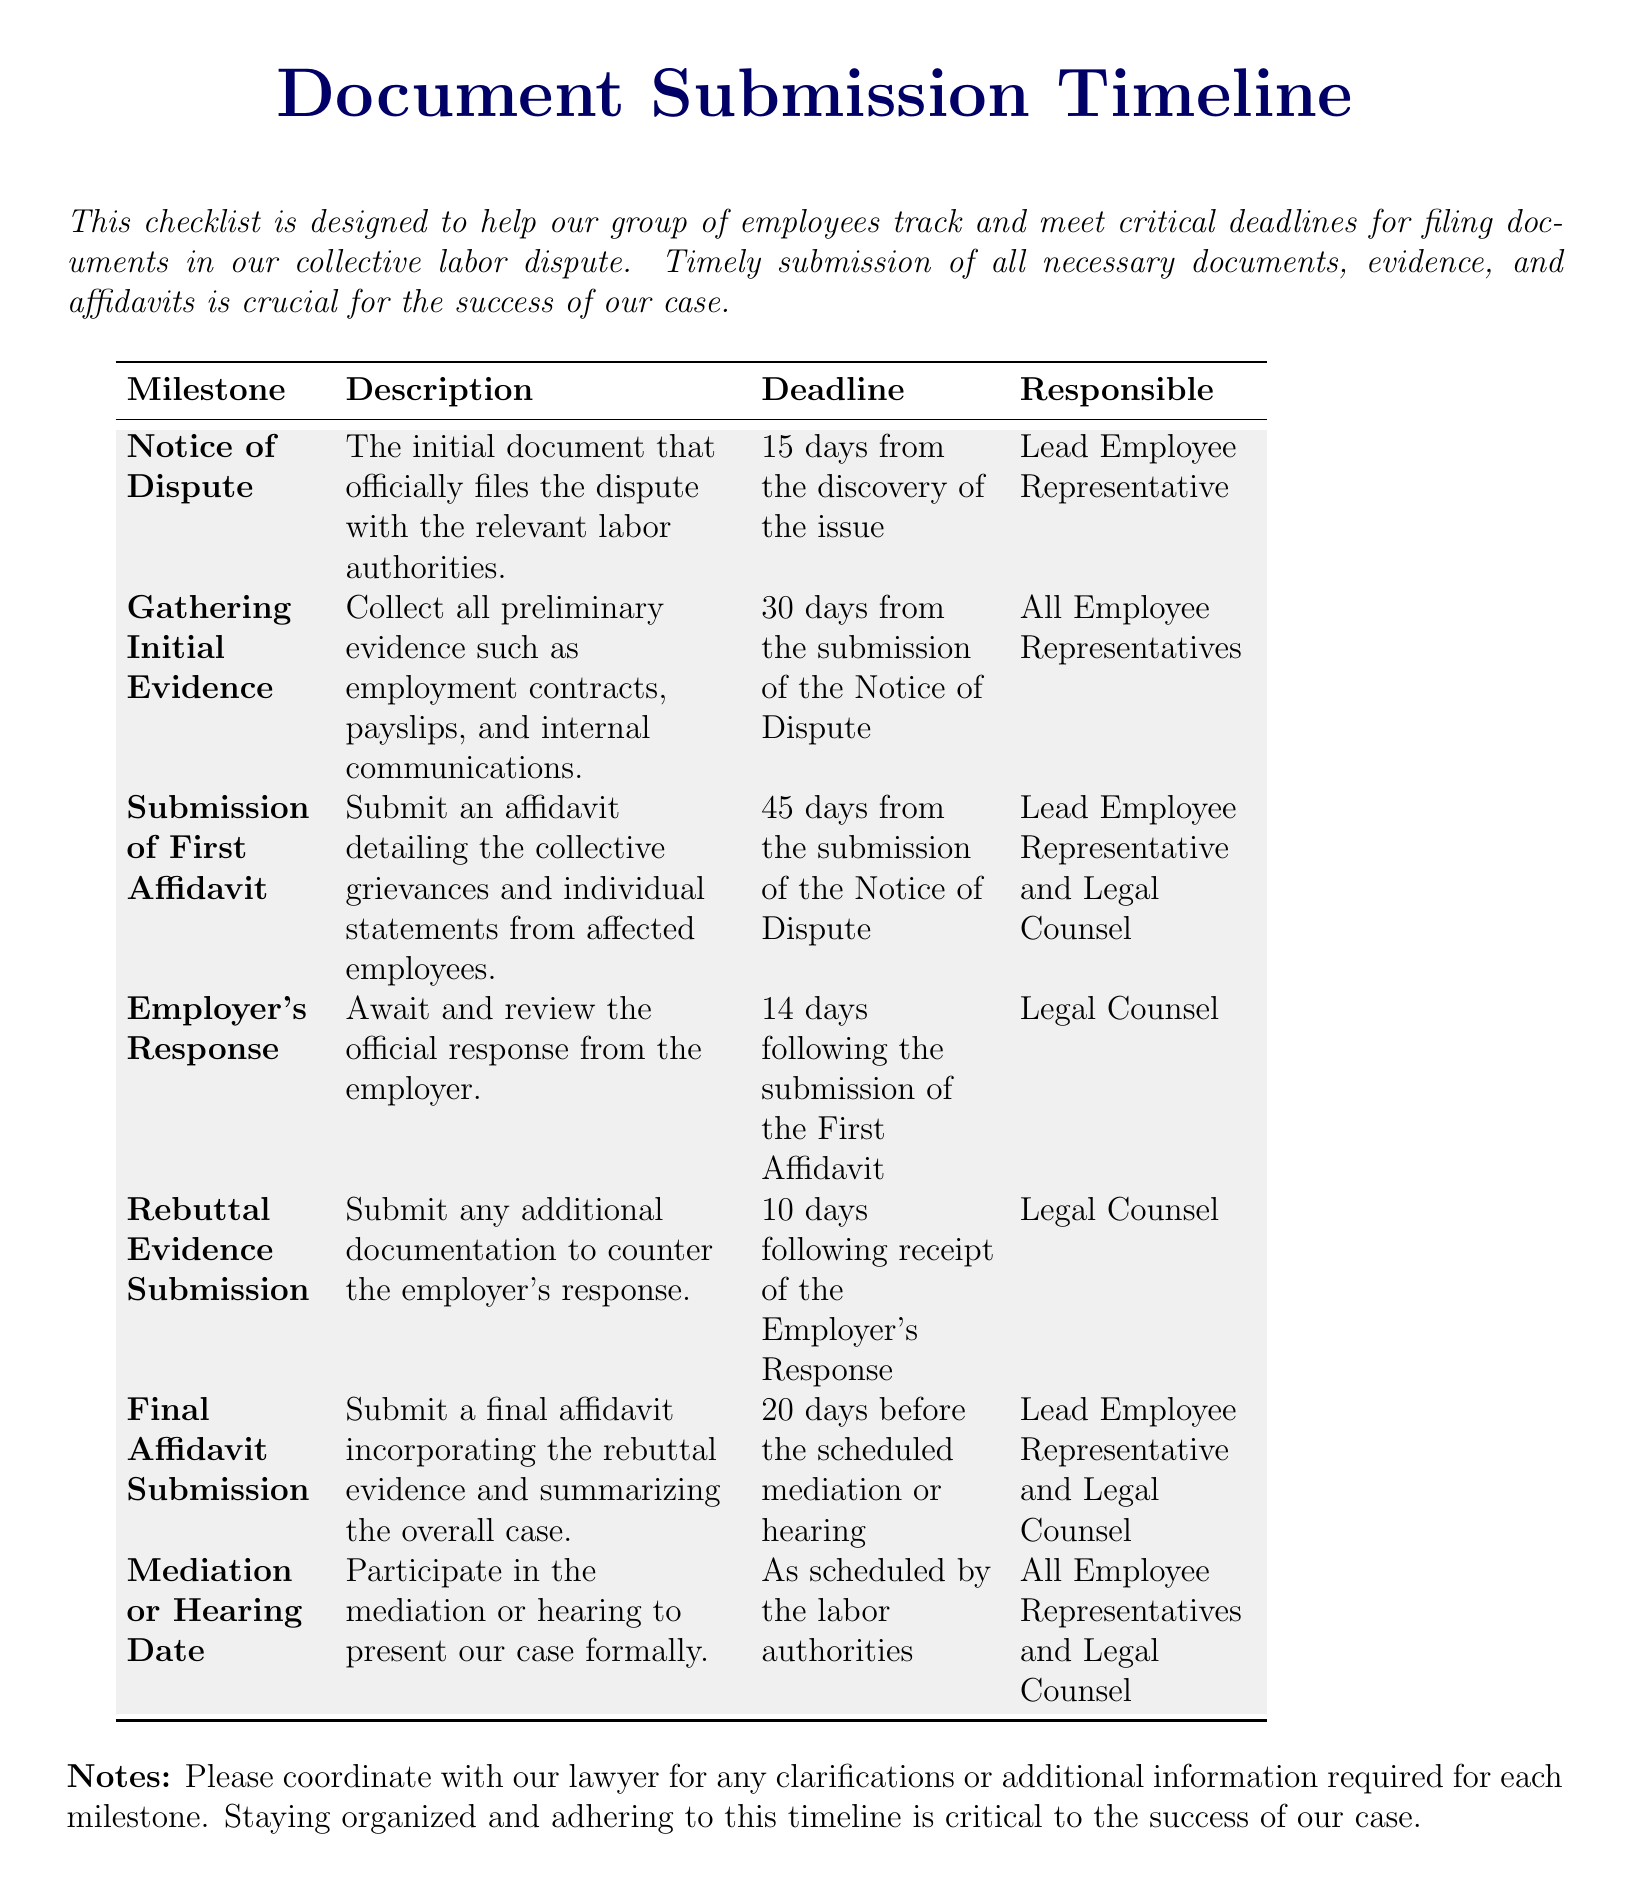What is the first milestone in the timeline? The first milestone is the initial document that officially files the dispute with the relevant labor authorities.
Answer: Notice of Dispute Who is responsible for gathering initial evidence? The document states that all employee representatives are responsible for this task.
Answer: All Employee Representatives What is the deadline for the submission of the first affidavit? The deadline is specified as 45 days from the submission of the Notice of Dispute.
Answer: 45 days from the submission of the Notice of Dispute How long do we have to wait for the employer's response? It is mentioned that the response will be reviewed 14 days following the submission of the First Affidavit.
Answer: 14 days What document must be submitted 20 days before the scheduled mediation or hearing? The document calls for a final affidavit incorporating the rebuttal evidence and summarizing the overall case.
Answer: Final Affidavit Submission Who is responsible for the final affidavit submission? The responsible parties for this submission include the Lead Employee Representative and Legal Counsel, as specified in the document.
Answer: Lead Employee Representative and Legal Counsel What is the deadline to submit rebuttal evidence? The document indicates that this should be done 10 days following receipt of the Employer's Response.
Answer: 10 days following receipt of the Employer's Response What should we do on the mediation or hearing date? The timeline indicates that our group should participate in the mediation or hearing to formally present our case.
Answer: Participate in the mediation or hearing What type of document is this timeline categorized as? The nature of this document is a checklist designed to track and meet critical deadlines for filing documents in the dispute.
Answer: Checklist 